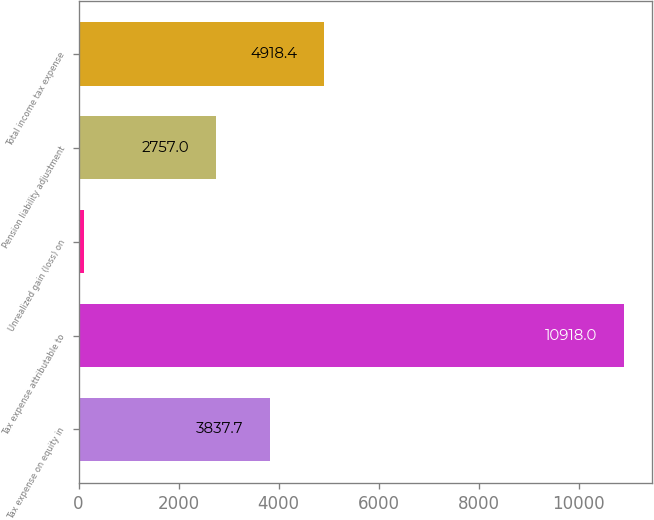Convert chart. <chart><loc_0><loc_0><loc_500><loc_500><bar_chart><fcel>Tax expense on equity in<fcel>Tax expense attributable to<fcel>Unrealized gain (loss) on<fcel>Pension liability adjustment<fcel>Total income tax expense<nl><fcel>3837.7<fcel>10918<fcel>111<fcel>2757<fcel>4918.4<nl></chart> 